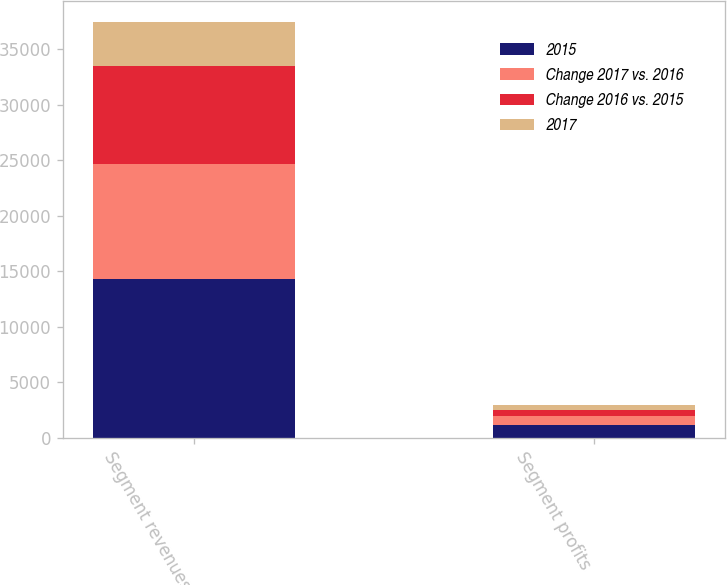Convert chart. <chart><loc_0><loc_0><loc_500><loc_500><stacked_bar_chart><ecel><fcel>Segment revenues<fcel>Segment profits<nl><fcel>2015<fcel>14300<fcel>1182<nl><fcel>Change 2017 vs. 2016<fcel>10376<fcel>777<nl><fcel>Change 2016 vs. 2015<fcel>8825<fcel>561<nl><fcel>2017<fcel>3924<fcel>405<nl></chart> 